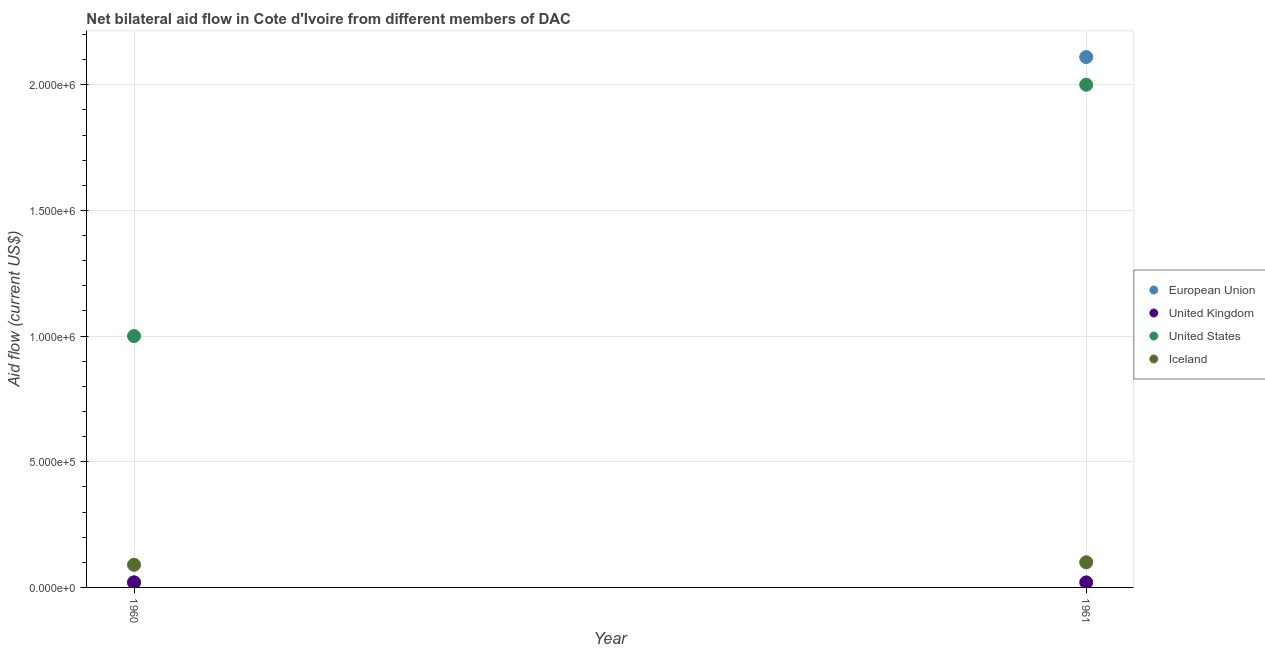How many different coloured dotlines are there?
Keep it short and to the point. 4. Is the number of dotlines equal to the number of legend labels?
Your response must be concise. Yes. What is the amount of aid given by uk in 1961?
Keep it short and to the point. 2.00e+04. Across all years, what is the maximum amount of aid given by us?
Your answer should be very brief. 2.00e+06. Across all years, what is the minimum amount of aid given by iceland?
Make the answer very short. 9.00e+04. In which year was the amount of aid given by us minimum?
Give a very brief answer. 1960. What is the total amount of aid given by eu in the graph?
Make the answer very short. 2.13e+06. What is the difference between the amount of aid given by iceland in 1960 and the amount of aid given by uk in 1961?
Offer a terse response. 7.00e+04. In the year 1960, what is the difference between the amount of aid given by us and amount of aid given by iceland?
Give a very brief answer. 9.10e+05. In how many years, is the amount of aid given by us greater than 500000 US$?
Your answer should be very brief. 2. What is the ratio of the amount of aid given by eu in 1960 to that in 1961?
Keep it short and to the point. 0.01. In how many years, is the amount of aid given by eu greater than the average amount of aid given by eu taken over all years?
Provide a succinct answer. 1. Is it the case that in every year, the sum of the amount of aid given by eu and amount of aid given by uk is greater than the amount of aid given by us?
Provide a succinct answer. No. How many dotlines are there?
Your response must be concise. 4. What is the difference between two consecutive major ticks on the Y-axis?
Offer a very short reply. 5.00e+05. Does the graph contain any zero values?
Offer a terse response. No. Does the graph contain grids?
Provide a succinct answer. Yes. Where does the legend appear in the graph?
Your answer should be compact. Center right. How many legend labels are there?
Offer a very short reply. 4. How are the legend labels stacked?
Make the answer very short. Vertical. What is the title of the graph?
Offer a terse response. Net bilateral aid flow in Cote d'Ivoire from different members of DAC. What is the label or title of the X-axis?
Your response must be concise. Year. What is the Aid flow (current US$) in European Union in 1960?
Offer a terse response. 2.00e+04. What is the Aid flow (current US$) of United Kingdom in 1960?
Give a very brief answer. 2.00e+04. What is the Aid flow (current US$) in Iceland in 1960?
Ensure brevity in your answer.  9.00e+04. What is the Aid flow (current US$) in European Union in 1961?
Make the answer very short. 2.11e+06. What is the Aid flow (current US$) of United Kingdom in 1961?
Ensure brevity in your answer.  2.00e+04. Across all years, what is the maximum Aid flow (current US$) of European Union?
Offer a terse response. 2.11e+06. Across all years, what is the minimum Aid flow (current US$) of United Kingdom?
Your response must be concise. 2.00e+04. What is the total Aid flow (current US$) of European Union in the graph?
Make the answer very short. 2.13e+06. What is the total Aid flow (current US$) in United States in the graph?
Provide a succinct answer. 3.00e+06. What is the difference between the Aid flow (current US$) in European Union in 1960 and that in 1961?
Provide a short and direct response. -2.09e+06. What is the difference between the Aid flow (current US$) in United States in 1960 and that in 1961?
Provide a succinct answer. -1.00e+06. What is the difference between the Aid flow (current US$) in European Union in 1960 and the Aid flow (current US$) in United Kingdom in 1961?
Your response must be concise. 0. What is the difference between the Aid flow (current US$) of European Union in 1960 and the Aid flow (current US$) of United States in 1961?
Provide a short and direct response. -1.98e+06. What is the difference between the Aid flow (current US$) in United Kingdom in 1960 and the Aid flow (current US$) in United States in 1961?
Offer a very short reply. -1.98e+06. What is the difference between the Aid flow (current US$) in United Kingdom in 1960 and the Aid flow (current US$) in Iceland in 1961?
Provide a succinct answer. -8.00e+04. What is the difference between the Aid flow (current US$) of United States in 1960 and the Aid flow (current US$) of Iceland in 1961?
Keep it short and to the point. 9.00e+05. What is the average Aid flow (current US$) in European Union per year?
Provide a short and direct response. 1.06e+06. What is the average Aid flow (current US$) of United Kingdom per year?
Your response must be concise. 2.00e+04. What is the average Aid flow (current US$) of United States per year?
Provide a short and direct response. 1.50e+06. What is the average Aid flow (current US$) in Iceland per year?
Offer a very short reply. 9.50e+04. In the year 1960, what is the difference between the Aid flow (current US$) of European Union and Aid flow (current US$) of United States?
Keep it short and to the point. -9.80e+05. In the year 1960, what is the difference between the Aid flow (current US$) in United Kingdom and Aid flow (current US$) in United States?
Give a very brief answer. -9.80e+05. In the year 1960, what is the difference between the Aid flow (current US$) of United Kingdom and Aid flow (current US$) of Iceland?
Offer a terse response. -7.00e+04. In the year 1960, what is the difference between the Aid flow (current US$) in United States and Aid flow (current US$) in Iceland?
Your answer should be compact. 9.10e+05. In the year 1961, what is the difference between the Aid flow (current US$) in European Union and Aid flow (current US$) in United Kingdom?
Ensure brevity in your answer.  2.09e+06. In the year 1961, what is the difference between the Aid flow (current US$) in European Union and Aid flow (current US$) in United States?
Offer a terse response. 1.10e+05. In the year 1961, what is the difference between the Aid flow (current US$) in European Union and Aid flow (current US$) in Iceland?
Your answer should be very brief. 2.01e+06. In the year 1961, what is the difference between the Aid flow (current US$) of United Kingdom and Aid flow (current US$) of United States?
Keep it short and to the point. -1.98e+06. In the year 1961, what is the difference between the Aid flow (current US$) in United States and Aid flow (current US$) in Iceland?
Provide a short and direct response. 1.90e+06. What is the ratio of the Aid flow (current US$) in European Union in 1960 to that in 1961?
Your answer should be compact. 0.01. What is the ratio of the Aid flow (current US$) in United Kingdom in 1960 to that in 1961?
Your answer should be compact. 1. What is the ratio of the Aid flow (current US$) in Iceland in 1960 to that in 1961?
Offer a terse response. 0.9. What is the difference between the highest and the second highest Aid flow (current US$) of European Union?
Ensure brevity in your answer.  2.09e+06. What is the difference between the highest and the second highest Aid flow (current US$) of United Kingdom?
Offer a terse response. 0. What is the difference between the highest and the second highest Aid flow (current US$) in United States?
Your answer should be compact. 1.00e+06. What is the difference between the highest and the lowest Aid flow (current US$) in European Union?
Keep it short and to the point. 2.09e+06. What is the difference between the highest and the lowest Aid flow (current US$) of United Kingdom?
Offer a terse response. 0. What is the difference between the highest and the lowest Aid flow (current US$) of United States?
Provide a succinct answer. 1.00e+06. What is the difference between the highest and the lowest Aid flow (current US$) in Iceland?
Your response must be concise. 10000. 